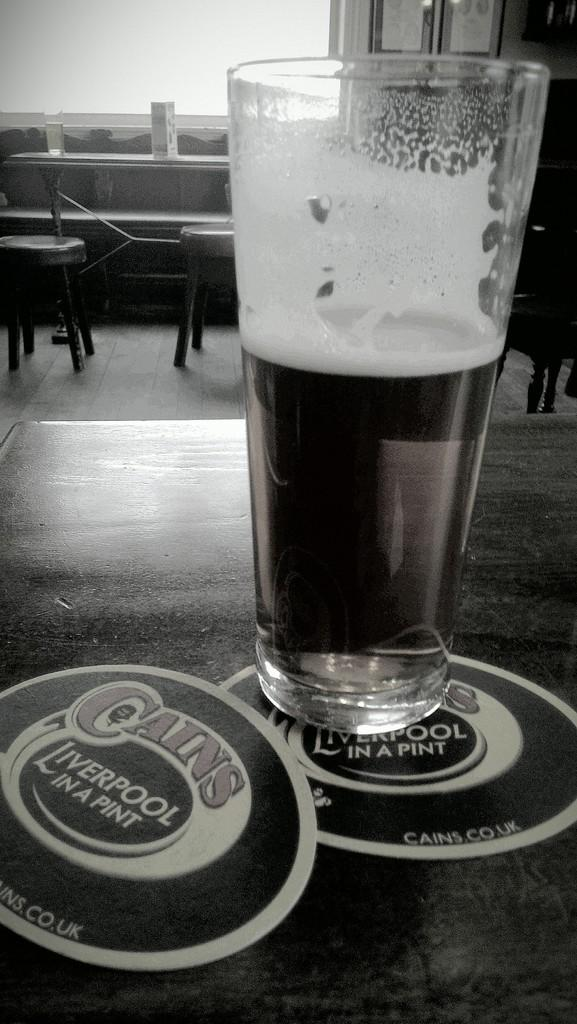What is in the glass that is visible in the image? There is a glass of wine in the image. Where is the glass of wine located? The glass of wine is on a table. What information can be found on the glass of wine? There are labels associated with the glass of wine. What can be seen in the background of the image? There is a chair, a table, a window, and frames attached to the wall in the background of the image. What type of polish is being applied to the window in the image? There is no polish or application process visible in the image; it only shows a glass of wine, a table, and elements in the background. 